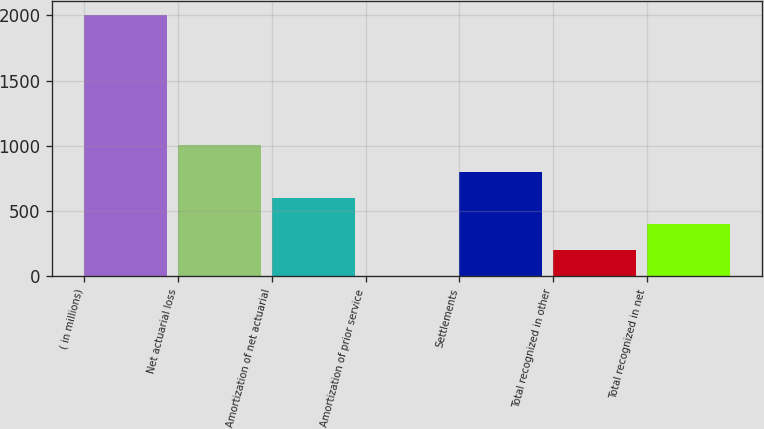<chart> <loc_0><loc_0><loc_500><loc_500><bar_chart><fcel>( in millions)<fcel>Net actuarial loss<fcel>Amortization of net actuarial<fcel>Amortization of prior service<fcel>Settlements<fcel>Total recognized in other<fcel>Total recognized in net<nl><fcel>2007<fcel>1004<fcel>602.8<fcel>1<fcel>803.4<fcel>201.6<fcel>402.2<nl></chart> 